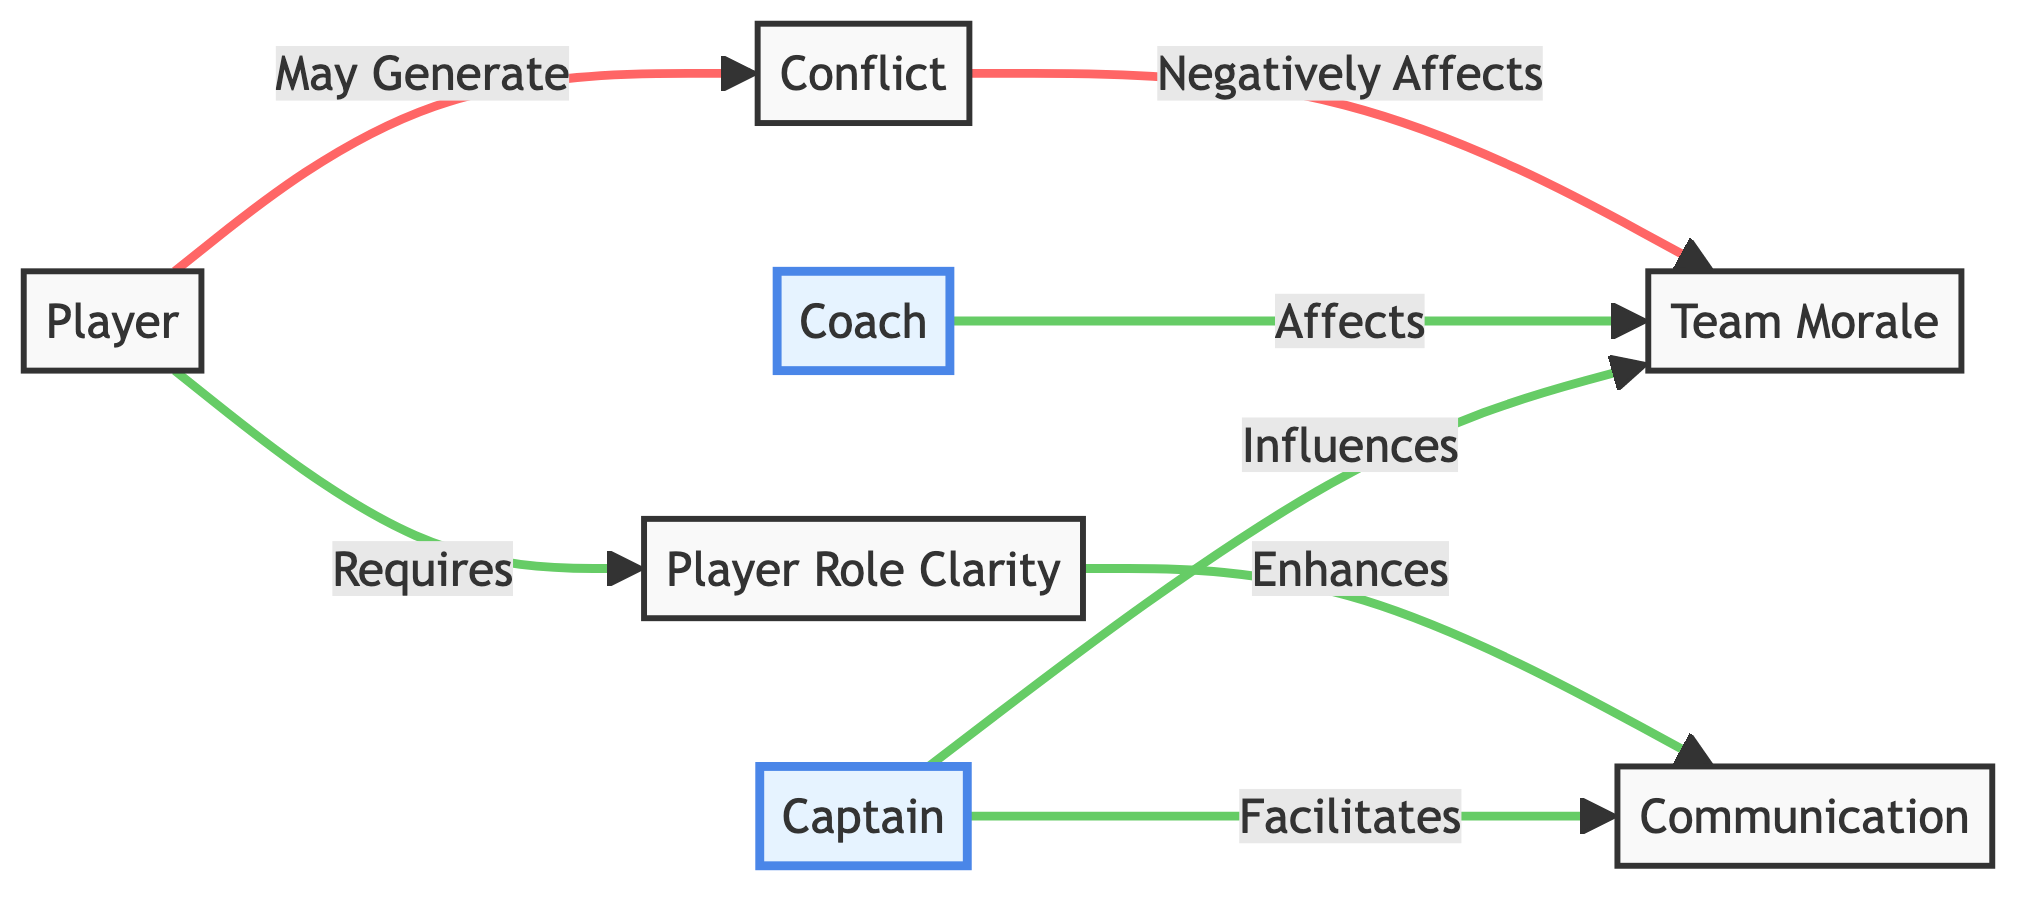What is the total number of nodes in the diagram? The diagram lists the following nodes: Player, Captain, Coach, Team Morale, Communication, Conflict, and Player Role Clarity, totaling seven nodes.
Answer: 7 Which node is influenced by the Captain? The edge from the Captain points to the Team Morale, indicating that the Captain influences Team Morale.
Answer: Team Morale What is the relationship between Communication and Player Role Clarity? The diagram shows an arrow from Player Role Clarity to Communication labeled "Enhances," which indicates that Player Role Clarity enhances Communication.
Answer: Enhances How does Conflict affect Team Morale? The edge from Conflict to Team Morale is labeled "Negatively Affects," indicating that conflict has a detrimental impact on team morale.
Answer: Negatively Affects Who facilitates Communication within the team? The edge from Captain to Communication is labeled "Facilitates," indicating that the Captain plays a role in facilitating communication within the team.
Answer: Captain What kind of player dynamics may generate Conflict? The edge from Player to Conflict is labeled "May Generate," which implies that players can create or contribute to conflict within the team.
Answer: May Generate What enhances Communication between team members? The relationship shown in the diagram indicates that improved Player Role Clarity enhances Communication among players and coaching staff.
Answer: Player Role Clarity How many edges are present in the diagram? The edges shown in the diagram are: Captain to Team Morale, Coach to Team Morale, Captain to Communication, Player to Conflict, Conflict to Team Morale, Player Role Clarity to Communication, and Player to Player Role Clarity, totaling six edges.
Answer: 6 What is the influence of the Coach on Team Morale? The edge from Coach to Team Morale is labeled "Affects," which signifies that the Coach has an influence on the morale of the team.
Answer: Affects 